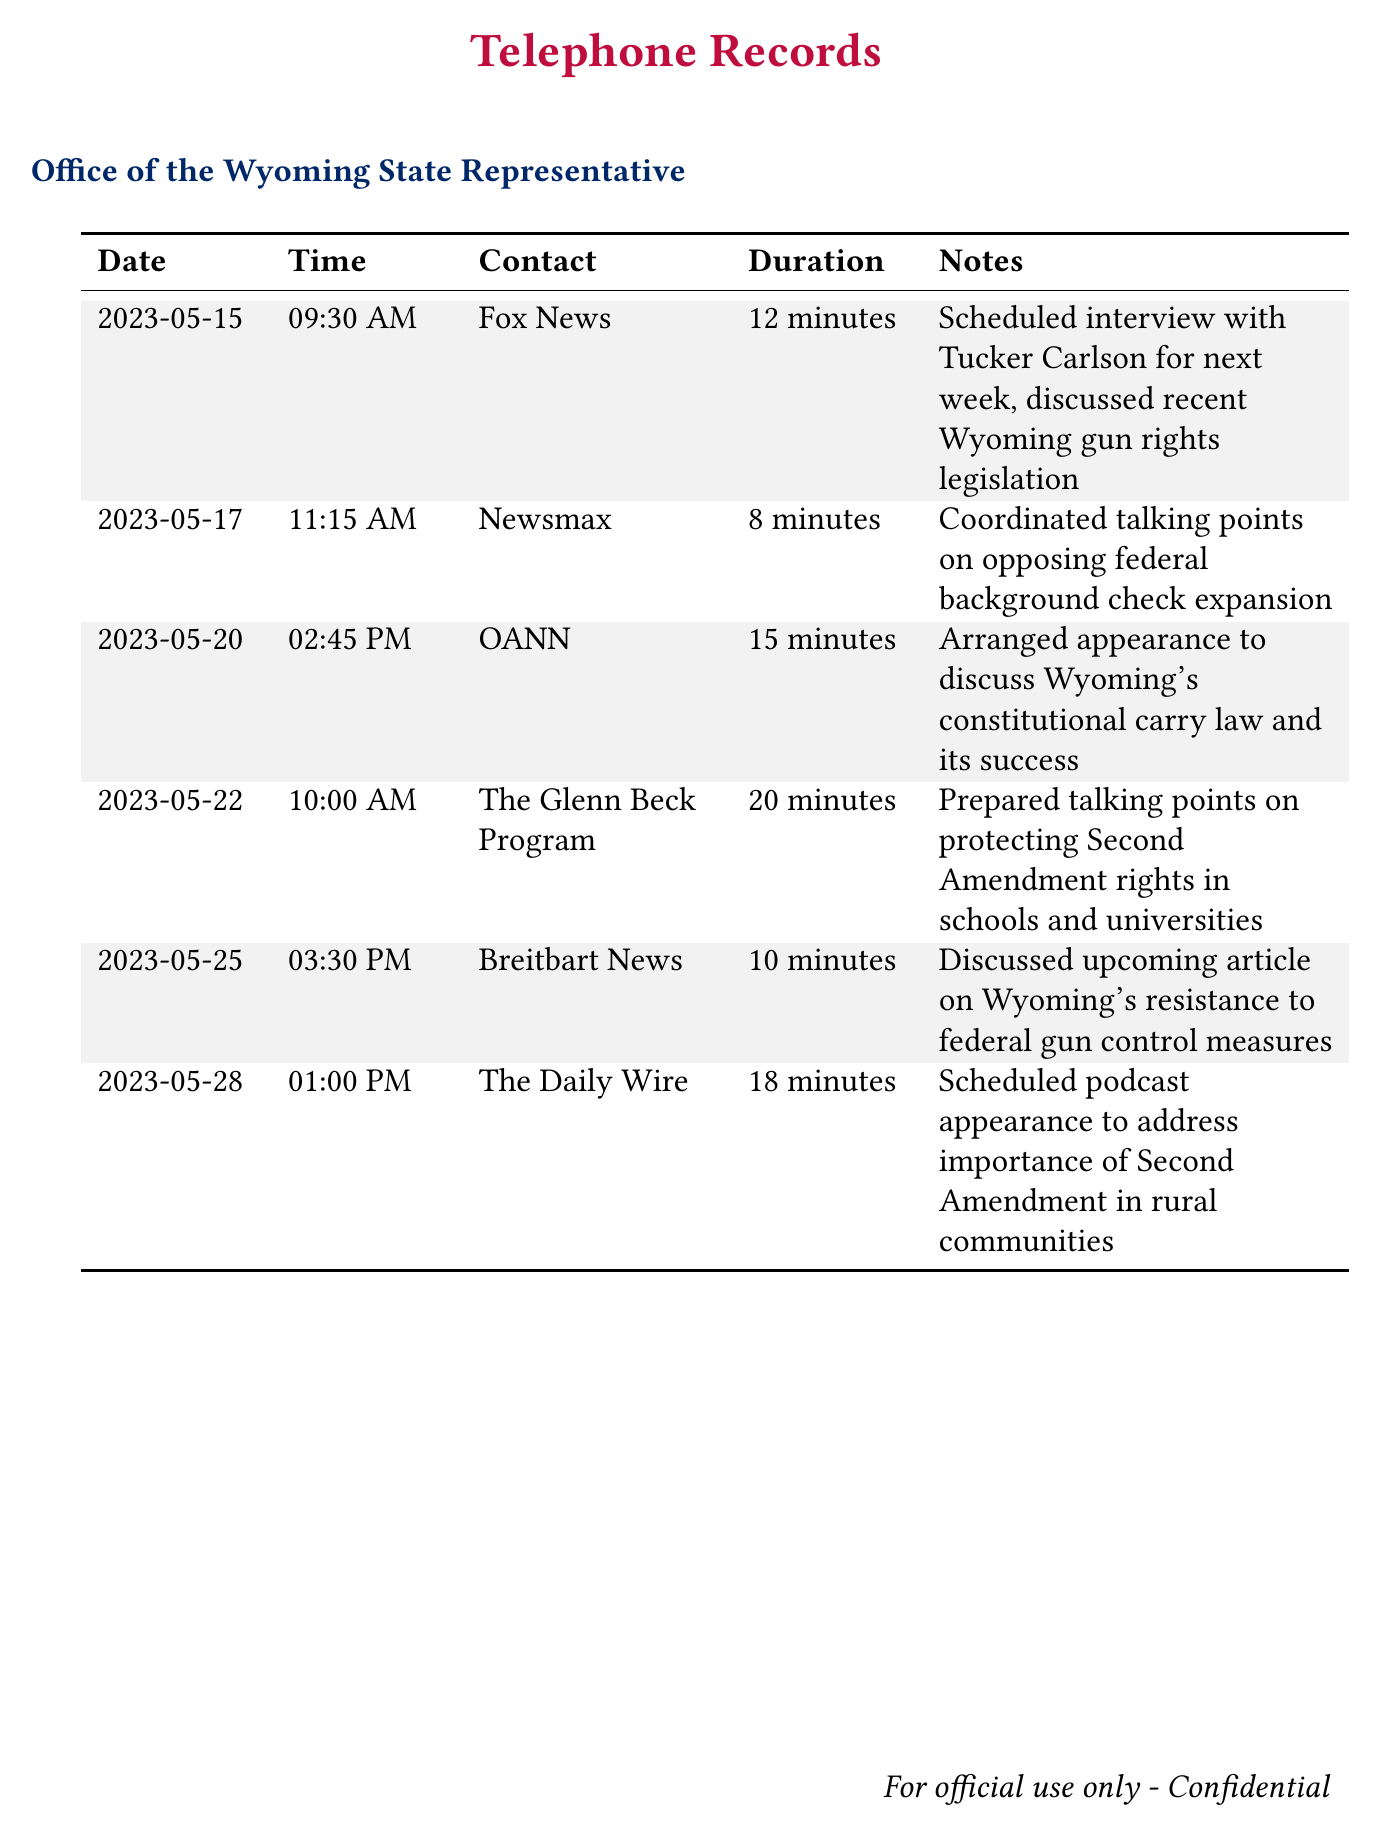what date was the call with Fox News? The call with Fox News occurred on May 15, 2023.
Answer: May 15, 2023 how long was the call with Newsmax? The duration of the call with Newsmax was 8 minutes.
Answer: 8 minutes which media outlet was contacted on May 22? On May 22, The Glenn Beck Program was contacted.
Answer: The Glenn Beck Program what topic was discussed during the call with OANN? The call with OANN discussed Wyoming's constitutional carry law and its success.
Answer: Wyoming's constitutional carry law how many minutes was the scheduled podcast appearance with The Daily Wire? The scheduled podcast appearance with The Daily Wire was 18 minutes long.
Answer: 18 minutes which media outlet was mentioned in relation to federal background check expansion? Newsmax was mentioned regarding federal background check expansion.
Answer: Newsmax what is the main focus of the telephone records? The main focus of the records is scheduling interviews and discussing talking points on Second Amendment rights.
Answer: Second Amendment rights who was the representative speaking to these media outlets? The documents imply a Wyoming State Representative, though the name isn't explicitly mentioned.
Answer: Wyoming State Representative how many calls are listed in total? There are six calls listed in total.
Answer: six 